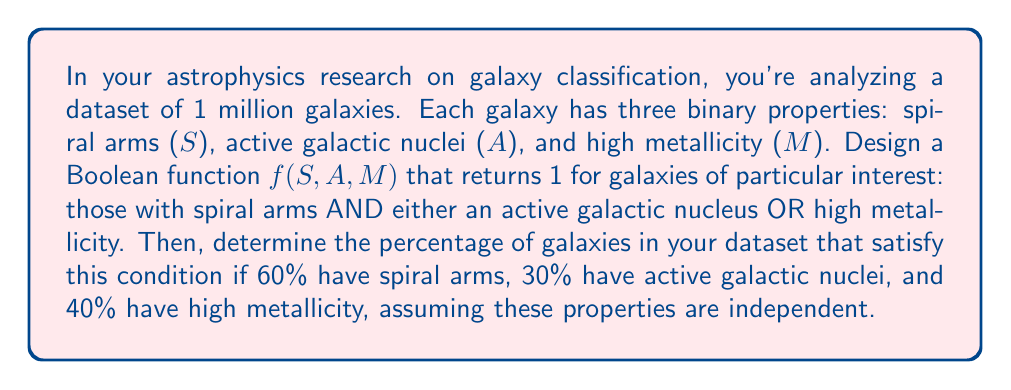Solve this math problem. 1. First, let's formulate the Boolean function:
   $f(S,A,M) = S \cdot (A + M)$
   This function returns 1 when S is true AND either A OR M is true.

2. To calculate the percentage of galaxies satisfying this condition, we need to find $P(S \cdot (A + M))$.

3. Given:
   $P(S) = 0.60$
   $P(A) = 0.30$
   $P(M) = 0.40$

4. Using the properties of Boolean algebra and probability:
   $P(S \cdot (A + M)) = P(S) \cdot P(A + M)$

5. To find $P(A + M)$:
   $P(A + M) = P(A) + P(M) - P(A \cdot M)$
   Since A and M are independent, $P(A \cdot M) = P(A) \cdot P(M)$
   $P(A + M) = 0.30 + 0.40 - (0.30 \cdot 0.40) = 0.58$

6. Now we can calculate the final probability:
   $P(S \cdot (A + M)) = 0.60 \cdot 0.58 = 0.348$

7. Convert to percentage:
   $0.348 \cdot 100\% = 34.8\%$
Answer: 34.8% 